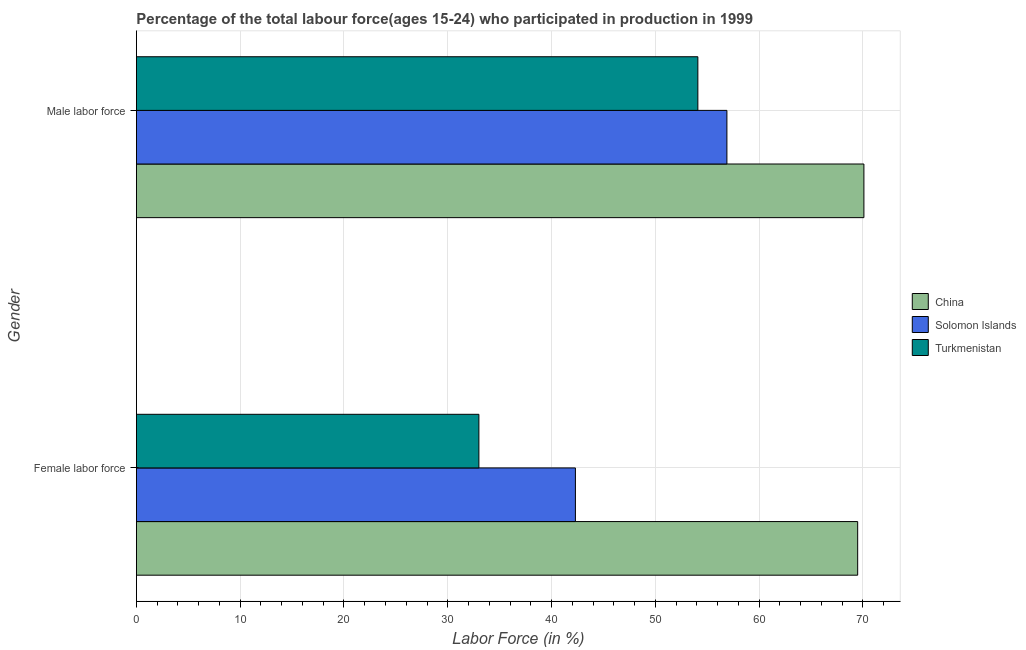Are the number of bars per tick equal to the number of legend labels?
Provide a succinct answer. Yes. What is the label of the 2nd group of bars from the top?
Give a very brief answer. Female labor force. What is the percentage of male labour force in Solomon Islands?
Make the answer very short. 56.9. Across all countries, what is the maximum percentage of male labour force?
Give a very brief answer. 70.1. Across all countries, what is the minimum percentage of male labour force?
Keep it short and to the point. 54.1. In which country was the percentage of male labour force maximum?
Give a very brief answer. China. In which country was the percentage of male labour force minimum?
Provide a short and direct response. Turkmenistan. What is the total percentage of male labour force in the graph?
Provide a short and direct response. 181.1. What is the difference between the percentage of male labour force in Turkmenistan and that in China?
Provide a short and direct response. -16. What is the difference between the percentage of female labor force in Turkmenistan and the percentage of male labour force in Solomon Islands?
Give a very brief answer. -23.9. What is the average percentage of female labor force per country?
Offer a very short reply. 48.27. What is the difference between the percentage of male labour force and percentage of female labor force in Solomon Islands?
Your answer should be very brief. 14.6. What is the ratio of the percentage of male labour force in Turkmenistan to that in China?
Offer a terse response. 0.77. Is the percentage of female labor force in Solomon Islands less than that in China?
Ensure brevity in your answer.  Yes. What does the 3rd bar from the bottom in Female labor force represents?
Your answer should be very brief. Turkmenistan. How many bars are there?
Your answer should be very brief. 6. Are all the bars in the graph horizontal?
Offer a terse response. Yes. What is the difference between two consecutive major ticks on the X-axis?
Your response must be concise. 10. Does the graph contain grids?
Your answer should be compact. Yes. Where does the legend appear in the graph?
Provide a succinct answer. Center right. How many legend labels are there?
Ensure brevity in your answer.  3. How are the legend labels stacked?
Provide a short and direct response. Vertical. What is the title of the graph?
Provide a succinct answer. Percentage of the total labour force(ages 15-24) who participated in production in 1999. What is the label or title of the X-axis?
Make the answer very short. Labor Force (in %). What is the Labor Force (in %) of China in Female labor force?
Ensure brevity in your answer.  69.5. What is the Labor Force (in %) of Solomon Islands in Female labor force?
Provide a succinct answer. 42.3. What is the Labor Force (in %) in Turkmenistan in Female labor force?
Offer a very short reply. 33. What is the Labor Force (in %) in China in Male labor force?
Provide a succinct answer. 70.1. What is the Labor Force (in %) in Solomon Islands in Male labor force?
Your response must be concise. 56.9. What is the Labor Force (in %) of Turkmenistan in Male labor force?
Offer a terse response. 54.1. Across all Gender, what is the maximum Labor Force (in %) in China?
Offer a very short reply. 70.1. Across all Gender, what is the maximum Labor Force (in %) in Solomon Islands?
Provide a succinct answer. 56.9. Across all Gender, what is the maximum Labor Force (in %) of Turkmenistan?
Provide a succinct answer. 54.1. Across all Gender, what is the minimum Labor Force (in %) of China?
Offer a terse response. 69.5. Across all Gender, what is the minimum Labor Force (in %) in Solomon Islands?
Your answer should be very brief. 42.3. Across all Gender, what is the minimum Labor Force (in %) in Turkmenistan?
Ensure brevity in your answer.  33. What is the total Labor Force (in %) of China in the graph?
Your answer should be very brief. 139.6. What is the total Labor Force (in %) of Solomon Islands in the graph?
Ensure brevity in your answer.  99.2. What is the total Labor Force (in %) of Turkmenistan in the graph?
Give a very brief answer. 87.1. What is the difference between the Labor Force (in %) in Solomon Islands in Female labor force and that in Male labor force?
Your answer should be compact. -14.6. What is the difference between the Labor Force (in %) of Turkmenistan in Female labor force and that in Male labor force?
Offer a very short reply. -21.1. What is the average Labor Force (in %) of China per Gender?
Provide a short and direct response. 69.8. What is the average Labor Force (in %) of Solomon Islands per Gender?
Offer a very short reply. 49.6. What is the average Labor Force (in %) of Turkmenistan per Gender?
Your answer should be very brief. 43.55. What is the difference between the Labor Force (in %) of China and Labor Force (in %) of Solomon Islands in Female labor force?
Make the answer very short. 27.2. What is the difference between the Labor Force (in %) of China and Labor Force (in %) of Turkmenistan in Female labor force?
Give a very brief answer. 36.5. What is the difference between the Labor Force (in %) in Solomon Islands and Labor Force (in %) in Turkmenistan in Female labor force?
Keep it short and to the point. 9.3. What is the difference between the Labor Force (in %) of Solomon Islands and Labor Force (in %) of Turkmenistan in Male labor force?
Offer a terse response. 2.8. What is the ratio of the Labor Force (in %) of Solomon Islands in Female labor force to that in Male labor force?
Ensure brevity in your answer.  0.74. What is the ratio of the Labor Force (in %) of Turkmenistan in Female labor force to that in Male labor force?
Keep it short and to the point. 0.61. What is the difference between the highest and the second highest Labor Force (in %) in China?
Offer a very short reply. 0.6. What is the difference between the highest and the second highest Labor Force (in %) in Solomon Islands?
Offer a very short reply. 14.6. What is the difference between the highest and the second highest Labor Force (in %) in Turkmenistan?
Offer a terse response. 21.1. What is the difference between the highest and the lowest Labor Force (in %) of Turkmenistan?
Give a very brief answer. 21.1. 